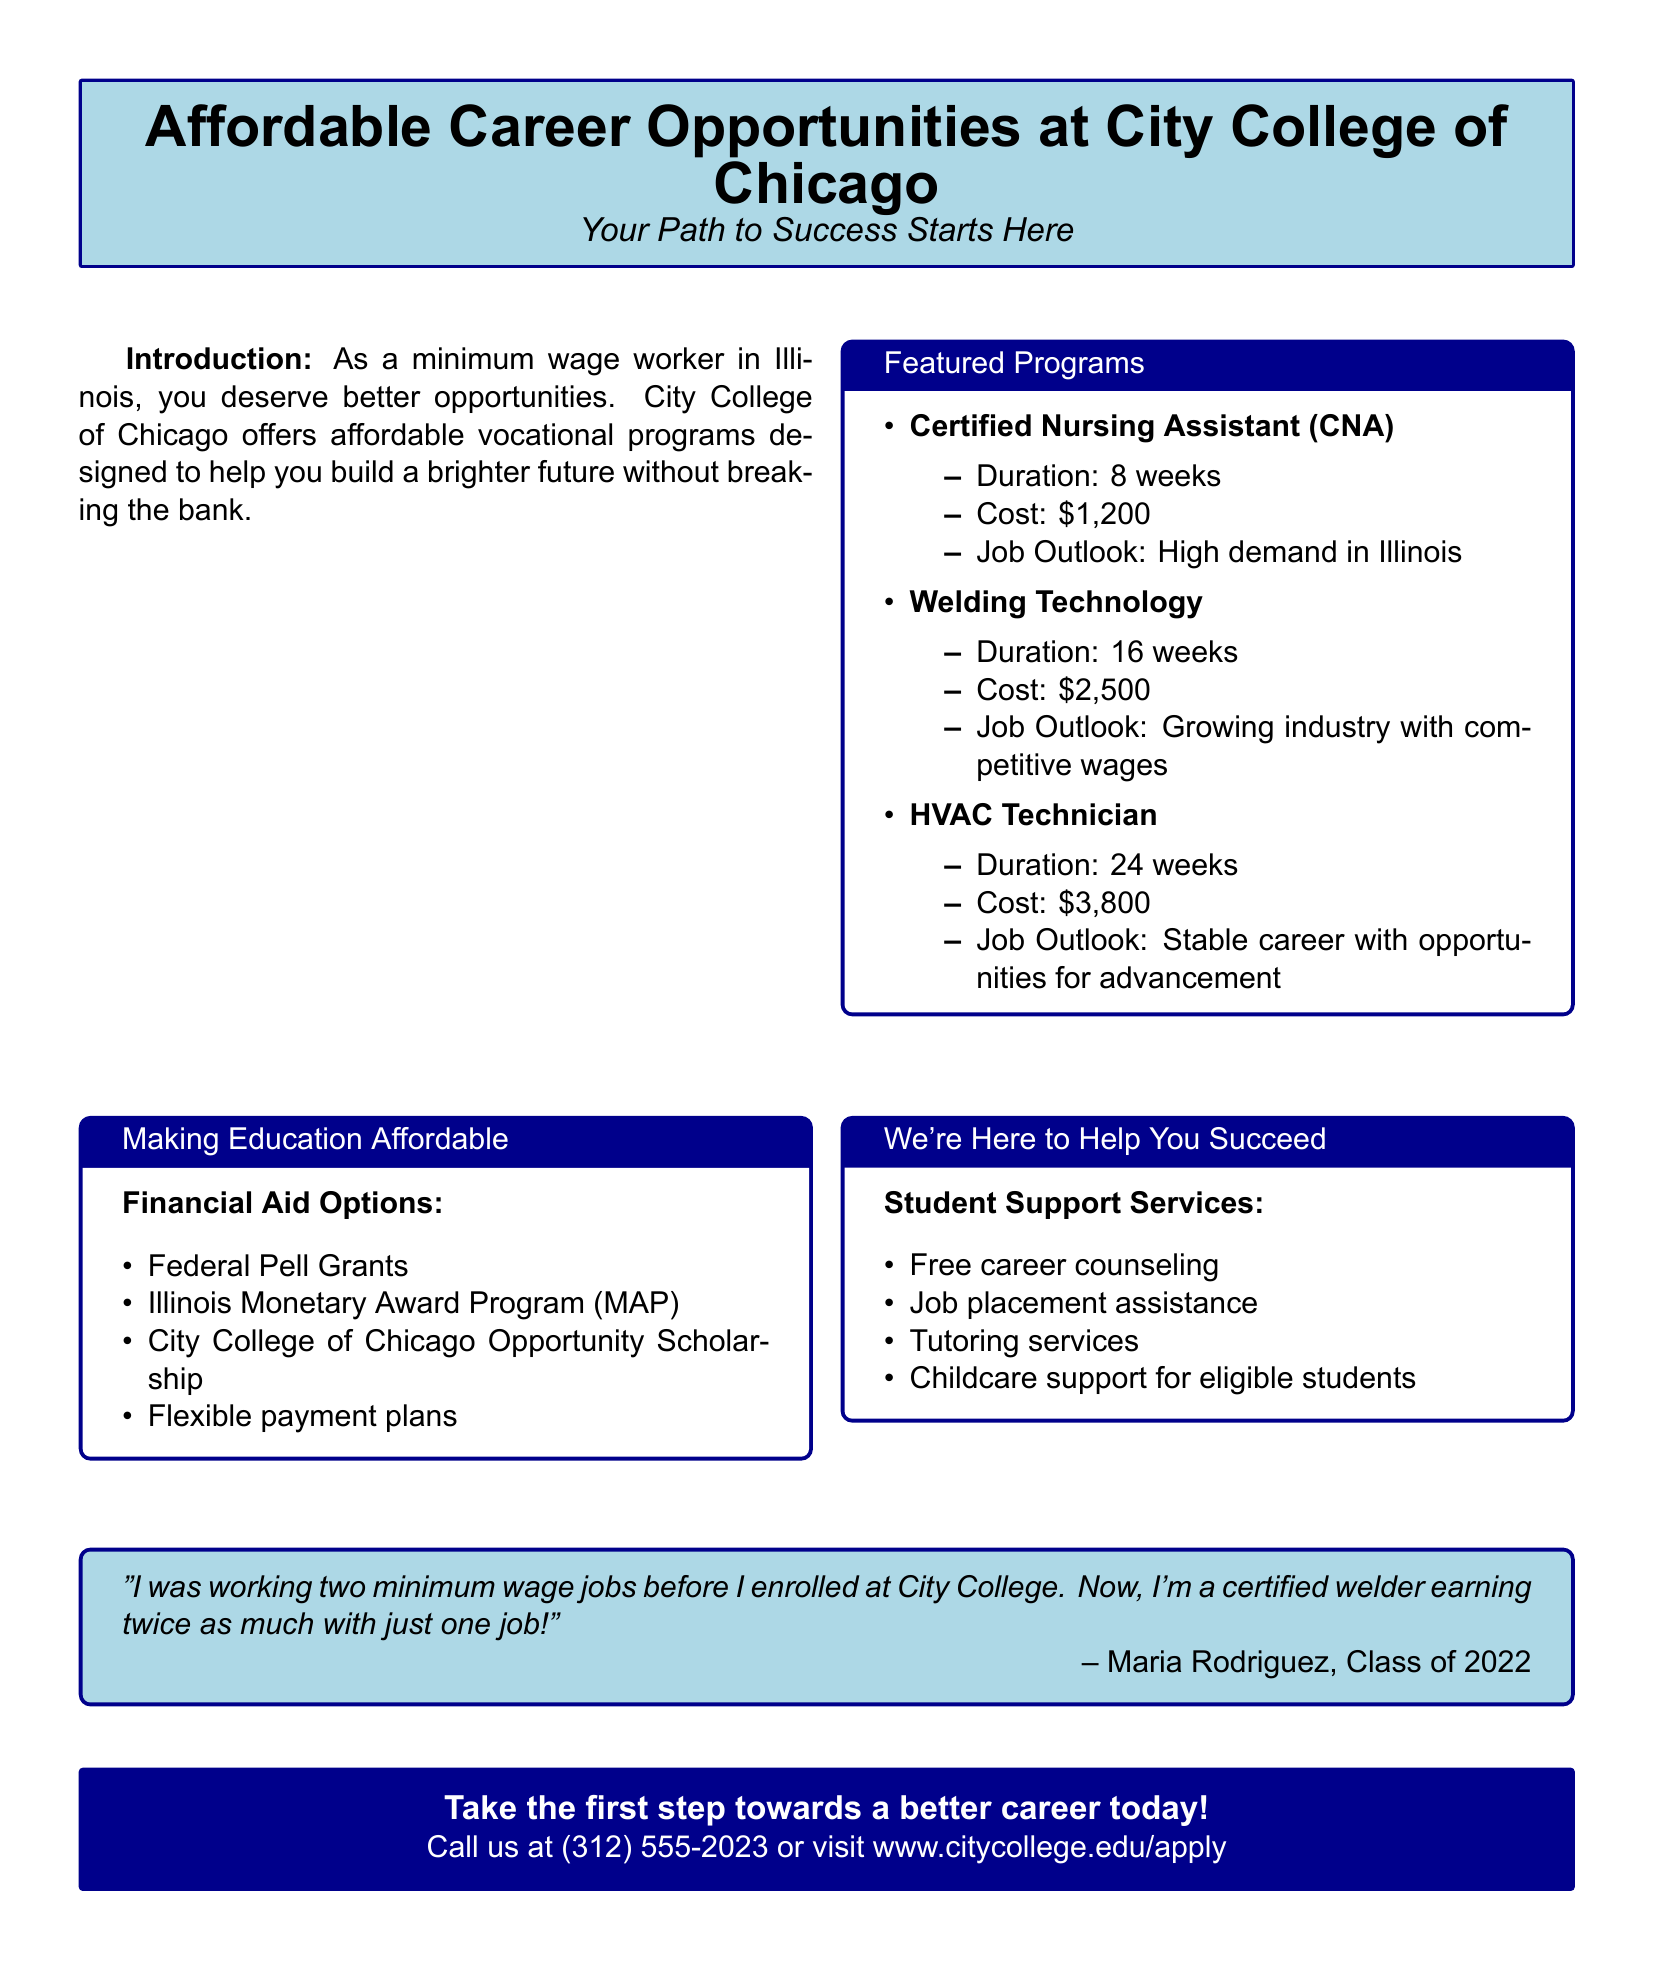What is the duration of the CNA program? The duration for the Certified Nursing Assistant program is mentioned in the document and is 8 weeks.
Answer: 8 weeks What is the cost of the Welding Technology program? The document states that the cost of the Welding Technology program is $2,500.
Answer: $2,500 What type of financial aid is offered by City College of Chicago? The document lists various financial aid options including the City College of Chicago Opportunity Scholarship, among others.
Answer: City College of Chicago Opportunity Scholarship What support service is available for eligible students? The document mentions childcare support as a service available for eligible students.
Answer: Childcare support How long does the HVAC Technician program last? The duration of the HVAC Technician program, as provided in the document, is 24 weeks.
Answer: 24 weeks Which program has a high demand in Illinois? According to the document, the Certified Nursing Assistant program has a high demand in Illinois.
Answer: Certified Nursing Assistant What is the total cost of the HVAC Technician program? The document provides the cost of the HVAC Technician program, which is specified as $3,800.
Answer: $3,800 What is the job outlook for Welding Technology? The document describes the job outlook for Welding Technology as a growing industry with competitive wages.
Answer: Growing industry with competitive wages What assistance does the document mention related to career preparation? The document lists free career counseling as a form of assistance related to career preparation.
Answer: Free career counseling 